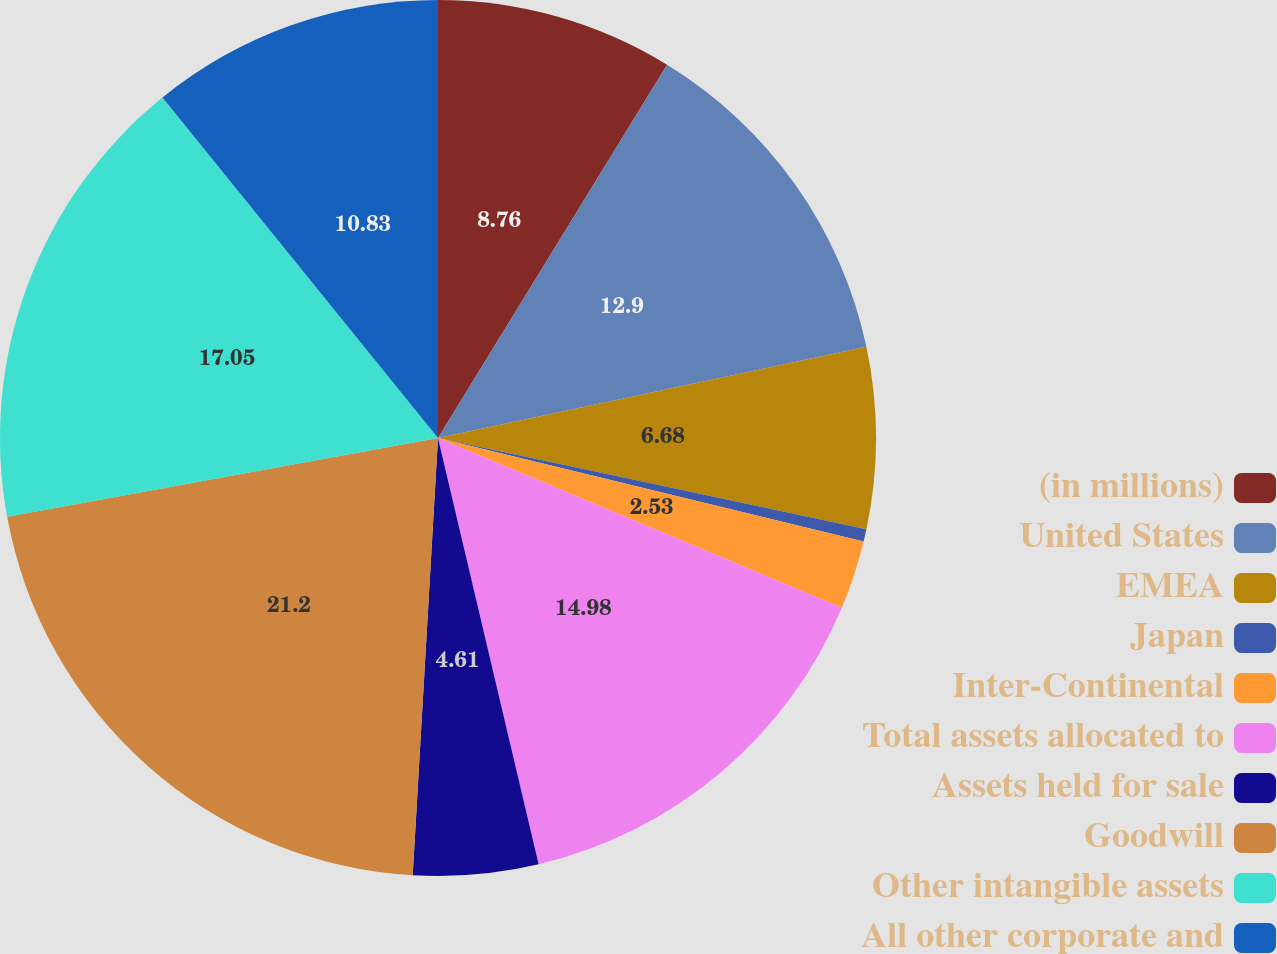<chart> <loc_0><loc_0><loc_500><loc_500><pie_chart><fcel>(in millions)<fcel>United States<fcel>EMEA<fcel>Japan<fcel>Inter-Continental<fcel>Total assets allocated to<fcel>Assets held for sale<fcel>Goodwill<fcel>Other intangible assets<fcel>All other corporate and<nl><fcel>8.76%<fcel>12.9%<fcel>6.68%<fcel>0.46%<fcel>2.53%<fcel>14.98%<fcel>4.61%<fcel>21.2%<fcel>17.05%<fcel>10.83%<nl></chart> 